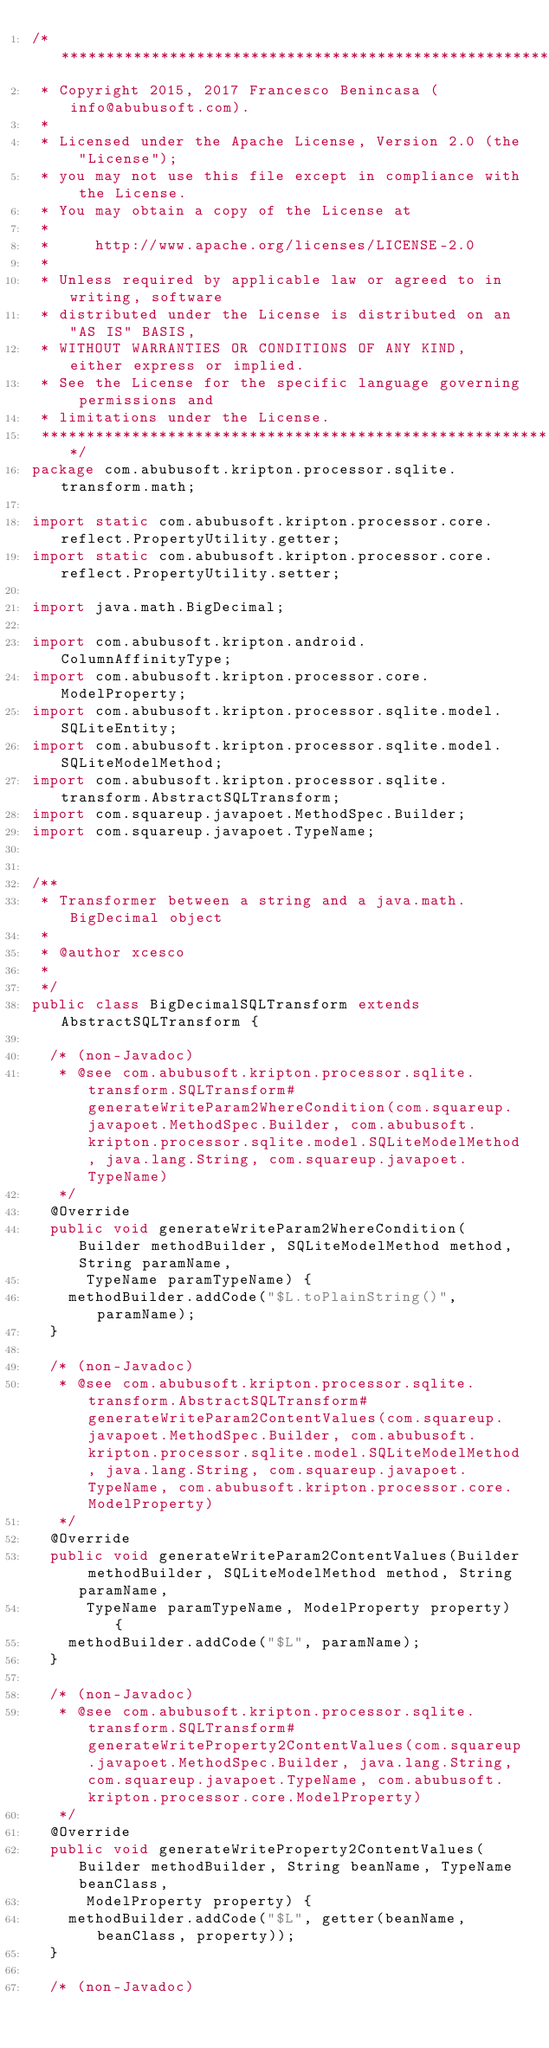<code> <loc_0><loc_0><loc_500><loc_500><_Java_>/*******************************************************************************
 * Copyright 2015, 2017 Francesco Benincasa (info@abubusoft.com).
 *
 * Licensed under the Apache License, Version 2.0 (the "License");
 * you may not use this file except in compliance with the License.
 * You may obtain a copy of the License at
 *
 *     http://www.apache.org/licenses/LICENSE-2.0
 *
 * Unless required by applicable law or agreed to in writing, software
 * distributed under the License is distributed on an "AS IS" BASIS,
 * WITHOUT WARRANTIES OR CONDITIONS OF ANY KIND, either express or implied.
 * See the License for the specific language governing permissions and
 * limitations under the License.
 *******************************************************************************/
package com.abubusoft.kripton.processor.sqlite.transform.math;

import static com.abubusoft.kripton.processor.core.reflect.PropertyUtility.getter;
import static com.abubusoft.kripton.processor.core.reflect.PropertyUtility.setter;

import java.math.BigDecimal;

import com.abubusoft.kripton.android.ColumnAffinityType;
import com.abubusoft.kripton.processor.core.ModelProperty;
import com.abubusoft.kripton.processor.sqlite.model.SQLiteEntity;
import com.abubusoft.kripton.processor.sqlite.model.SQLiteModelMethod;
import com.abubusoft.kripton.processor.sqlite.transform.AbstractSQLTransform;
import com.squareup.javapoet.MethodSpec.Builder;
import com.squareup.javapoet.TypeName;


/**
 * Transformer between a string and a java.math.BigDecimal object
 * 
 * @author xcesco
 *
 */
public class BigDecimalSQLTransform extends AbstractSQLTransform {

	/* (non-Javadoc)
	 * @see com.abubusoft.kripton.processor.sqlite.transform.SQLTransform#generateWriteParam2WhereCondition(com.squareup.javapoet.MethodSpec.Builder, com.abubusoft.kripton.processor.sqlite.model.SQLiteModelMethod, java.lang.String, com.squareup.javapoet.TypeName)
	 */
	@Override
	public void generateWriteParam2WhereCondition(Builder methodBuilder, SQLiteModelMethod method, String paramName,
			TypeName paramTypeName) {
		methodBuilder.addCode("$L.toPlainString()", paramName);
	}

	/* (non-Javadoc)
	 * @see com.abubusoft.kripton.processor.sqlite.transform.AbstractSQLTransform#generateWriteParam2ContentValues(com.squareup.javapoet.MethodSpec.Builder, com.abubusoft.kripton.processor.sqlite.model.SQLiteModelMethod, java.lang.String, com.squareup.javapoet.TypeName, com.abubusoft.kripton.processor.core.ModelProperty)
	 */
	@Override
	public void generateWriteParam2ContentValues(Builder methodBuilder, SQLiteModelMethod method, String paramName,
			TypeName paramTypeName, ModelProperty property) {
		methodBuilder.addCode("$L", paramName);
	}

	/* (non-Javadoc)
	 * @see com.abubusoft.kripton.processor.sqlite.transform.SQLTransform#generateWriteProperty2ContentValues(com.squareup.javapoet.MethodSpec.Builder, java.lang.String, com.squareup.javapoet.TypeName, com.abubusoft.kripton.processor.core.ModelProperty)
	 */
	@Override
	public void generateWriteProperty2ContentValues(Builder methodBuilder, String beanName, TypeName beanClass,
			ModelProperty property) {
		methodBuilder.addCode("$L", getter(beanName, beanClass, property));
	}

	/* (non-Javadoc)</code> 